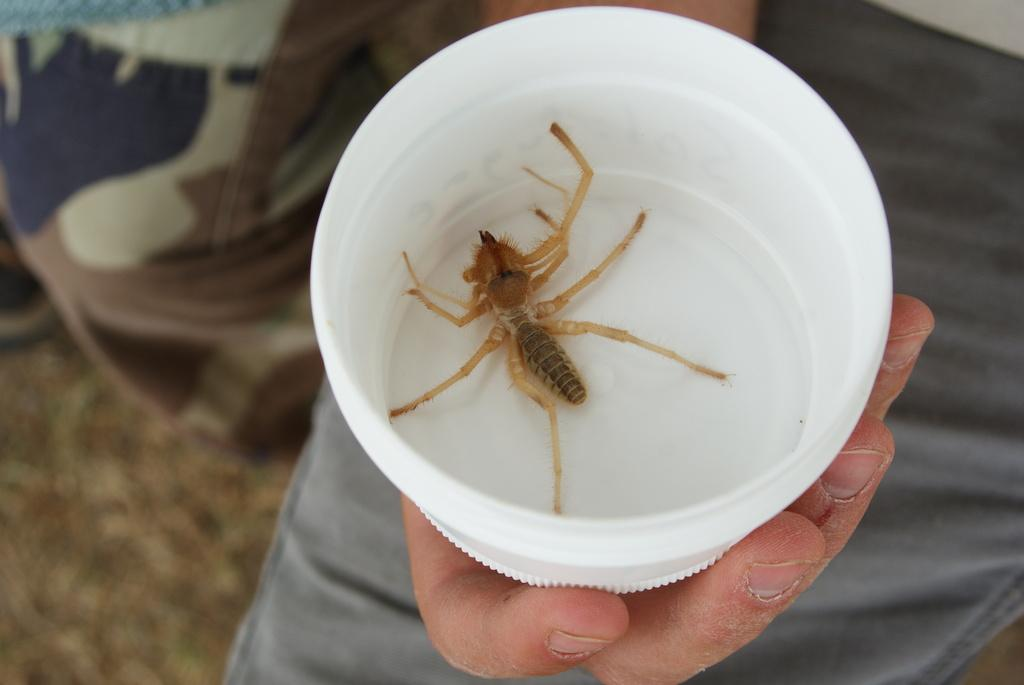What is the person in the image holding? The person is holding a bowl. What is inside the bowl? A spider is in the bowl. Can you describe the lighting in the image? The image was likely taken during the day, so there is natural light present. Where might the image have been taken? The image may have been taken on the ground, as there is no indication of elevation. What type of cart is the lawyer using to conduct science experiments in the image? There is no cart, lawyer, or science experiments present in the image. 